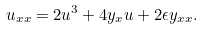<formula> <loc_0><loc_0><loc_500><loc_500>u _ { x x } = 2 u ^ { 3 } + 4 y _ { x } u + 2 \epsilon y _ { x x } .</formula> 